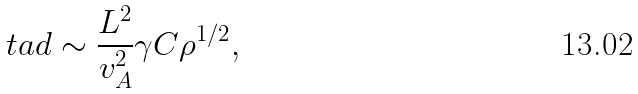Convert formula to latex. <formula><loc_0><loc_0><loc_500><loc_500>\ t a d \sim \frac { L ^ { 2 } } { v _ { A } ^ { 2 } } \gamma C \rho ^ { 1 / 2 } ,</formula> 